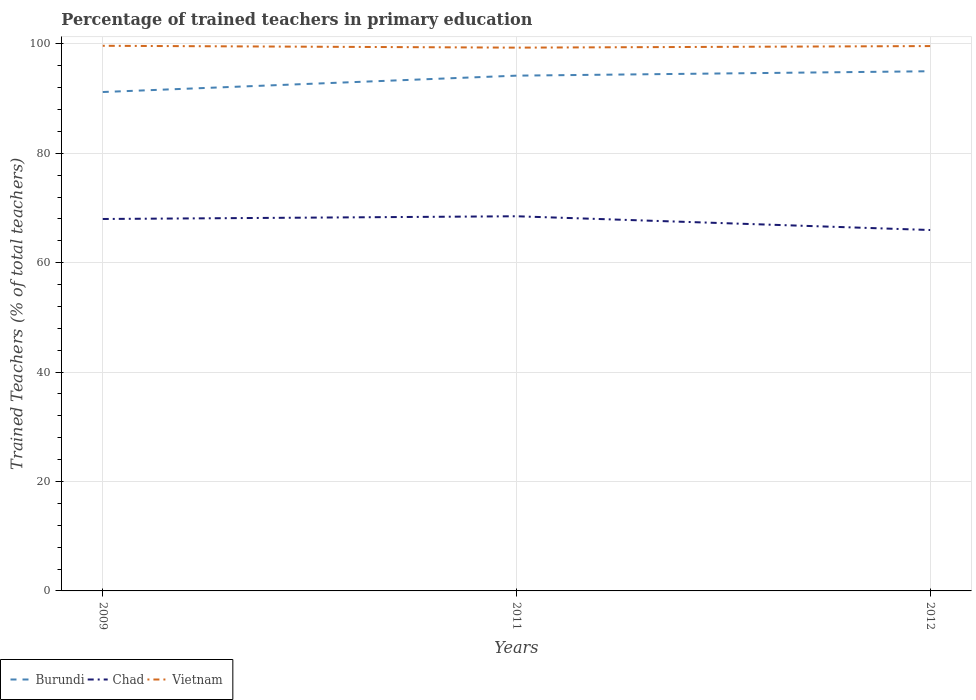How many different coloured lines are there?
Your answer should be very brief. 3. Across all years, what is the maximum percentage of trained teachers in Chad?
Provide a short and direct response. 65.97. What is the total percentage of trained teachers in Vietnam in the graph?
Make the answer very short. -0.29. What is the difference between the highest and the second highest percentage of trained teachers in Vietnam?
Give a very brief answer. 0.34. Is the percentage of trained teachers in Vietnam strictly greater than the percentage of trained teachers in Burundi over the years?
Give a very brief answer. No. How many lines are there?
Give a very brief answer. 3. What is the difference between two consecutive major ticks on the Y-axis?
Keep it short and to the point. 20. Are the values on the major ticks of Y-axis written in scientific E-notation?
Provide a succinct answer. No. Does the graph contain any zero values?
Your response must be concise. No. Does the graph contain grids?
Offer a terse response. Yes. Where does the legend appear in the graph?
Provide a short and direct response. Bottom left. How are the legend labels stacked?
Make the answer very short. Horizontal. What is the title of the graph?
Ensure brevity in your answer.  Percentage of trained teachers in primary education. Does "Panama" appear as one of the legend labels in the graph?
Ensure brevity in your answer.  No. What is the label or title of the X-axis?
Your answer should be very brief. Years. What is the label or title of the Y-axis?
Your answer should be compact. Trained Teachers (% of total teachers). What is the Trained Teachers (% of total teachers) of Burundi in 2009?
Offer a terse response. 91.19. What is the Trained Teachers (% of total teachers) of Chad in 2009?
Give a very brief answer. 67.98. What is the Trained Teachers (% of total teachers) of Vietnam in 2009?
Provide a succinct answer. 99.64. What is the Trained Teachers (% of total teachers) of Burundi in 2011?
Your response must be concise. 94.18. What is the Trained Teachers (% of total teachers) in Chad in 2011?
Give a very brief answer. 68.48. What is the Trained Teachers (% of total teachers) in Vietnam in 2011?
Provide a short and direct response. 99.3. What is the Trained Teachers (% of total teachers) of Burundi in 2012?
Ensure brevity in your answer.  94.99. What is the Trained Teachers (% of total teachers) of Chad in 2012?
Make the answer very short. 65.97. What is the Trained Teachers (% of total teachers) in Vietnam in 2012?
Keep it short and to the point. 99.59. Across all years, what is the maximum Trained Teachers (% of total teachers) in Burundi?
Make the answer very short. 94.99. Across all years, what is the maximum Trained Teachers (% of total teachers) in Chad?
Your answer should be very brief. 68.48. Across all years, what is the maximum Trained Teachers (% of total teachers) in Vietnam?
Keep it short and to the point. 99.64. Across all years, what is the minimum Trained Teachers (% of total teachers) in Burundi?
Make the answer very short. 91.19. Across all years, what is the minimum Trained Teachers (% of total teachers) in Chad?
Offer a terse response. 65.97. Across all years, what is the minimum Trained Teachers (% of total teachers) of Vietnam?
Keep it short and to the point. 99.3. What is the total Trained Teachers (% of total teachers) of Burundi in the graph?
Offer a terse response. 280.36. What is the total Trained Teachers (% of total teachers) of Chad in the graph?
Offer a terse response. 202.43. What is the total Trained Teachers (% of total teachers) of Vietnam in the graph?
Your response must be concise. 298.53. What is the difference between the Trained Teachers (% of total teachers) of Burundi in 2009 and that in 2011?
Your answer should be very brief. -2.99. What is the difference between the Trained Teachers (% of total teachers) of Chad in 2009 and that in 2011?
Ensure brevity in your answer.  -0.5. What is the difference between the Trained Teachers (% of total teachers) in Vietnam in 2009 and that in 2011?
Your response must be concise. 0.34. What is the difference between the Trained Teachers (% of total teachers) of Burundi in 2009 and that in 2012?
Provide a short and direct response. -3.8. What is the difference between the Trained Teachers (% of total teachers) of Chad in 2009 and that in 2012?
Keep it short and to the point. 2.02. What is the difference between the Trained Teachers (% of total teachers) in Vietnam in 2009 and that in 2012?
Give a very brief answer. 0.05. What is the difference between the Trained Teachers (% of total teachers) of Burundi in 2011 and that in 2012?
Offer a terse response. -0.81. What is the difference between the Trained Teachers (% of total teachers) of Chad in 2011 and that in 2012?
Provide a short and direct response. 2.51. What is the difference between the Trained Teachers (% of total teachers) of Vietnam in 2011 and that in 2012?
Give a very brief answer. -0.29. What is the difference between the Trained Teachers (% of total teachers) in Burundi in 2009 and the Trained Teachers (% of total teachers) in Chad in 2011?
Offer a very short reply. 22.71. What is the difference between the Trained Teachers (% of total teachers) of Burundi in 2009 and the Trained Teachers (% of total teachers) of Vietnam in 2011?
Offer a terse response. -8.11. What is the difference between the Trained Teachers (% of total teachers) of Chad in 2009 and the Trained Teachers (% of total teachers) of Vietnam in 2011?
Offer a terse response. -31.32. What is the difference between the Trained Teachers (% of total teachers) in Burundi in 2009 and the Trained Teachers (% of total teachers) in Chad in 2012?
Ensure brevity in your answer.  25.22. What is the difference between the Trained Teachers (% of total teachers) of Burundi in 2009 and the Trained Teachers (% of total teachers) of Vietnam in 2012?
Ensure brevity in your answer.  -8.4. What is the difference between the Trained Teachers (% of total teachers) in Chad in 2009 and the Trained Teachers (% of total teachers) in Vietnam in 2012?
Your response must be concise. -31.61. What is the difference between the Trained Teachers (% of total teachers) of Burundi in 2011 and the Trained Teachers (% of total teachers) of Chad in 2012?
Your answer should be very brief. 28.22. What is the difference between the Trained Teachers (% of total teachers) in Burundi in 2011 and the Trained Teachers (% of total teachers) in Vietnam in 2012?
Your response must be concise. -5.41. What is the difference between the Trained Teachers (% of total teachers) of Chad in 2011 and the Trained Teachers (% of total teachers) of Vietnam in 2012?
Your answer should be very brief. -31.11. What is the average Trained Teachers (% of total teachers) of Burundi per year?
Make the answer very short. 93.45. What is the average Trained Teachers (% of total teachers) of Chad per year?
Make the answer very short. 67.48. What is the average Trained Teachers (% of total teachers) in Vietnam per year?
Keep it short and to the point. 99.51. In the year 2009, what is the difference between the Trained Teachers (% of total teachers) of Burundi and Trained Teachers (% of total teachers) of Chad?
Provide a succinct answer. 23.21. In the year 2009, what is the difference between the Trained Teachers (% of total teachers) in Burundi and Trained Teachers (% of total teachers) in Vietnam?
Your answer should be very brief. -8.45. In the year 2009, what is the difference between the Trained Teachers (% of total teachers) in Chad and Trained Teachers (% of total teachers) in Vietnam?
Offer a terse response. -31.66. In the year 2011, what is the difference between the Trained Teachers (% of total teachers) in Burundi and Trained Teachers (% of total teachers) in Chad?
Offer a terse response. 25.7. In the year 2011, what is the difference between the Trained Teachers (% of total teachers) of Burundi and Trained Teachers (% of total teachers) of Vietnam?
Offer a very short reply. -5.12. In the year 2011, what is the difference between the Trained Teachers (% of total teachers) in Chad and Trained Teachers (% of total teachers) in Vietnam?
Give a very brief answer. -30.82. In the year 2012, what is the difference between the Trained Teachers (% of total teachers) of Burundi and Trained Teachers (% of total teachers) of Chad?
Give a very brief answer. 29.02. In the year 2012, what is the difference between the Trained Teachers (% of total teachers) in Burundi and Trained Teachers (% of total teachers) in Vietnam?
Keep it short and to the point. -4.6. In the year 2012, what is the difference between the Trained Teachers (% of total teachers) of Chad and Trained Teachers (% of total teachers) of Vietnam?
Make the answer very short. -33.62. What is the ratio of the Trained Teachers (% of total teachers) of Burundi in 2009 to that in 2011?
Your answer should be compact. 0.97. What is the ratio of the Trained Teachers (% of total teachers) in Vietnam in 2009 to that in 2011?
Your answer should be very brief. 1. What is the ratio of the Trained Teachers (% of total teachers) of Chad in 2009 to that in 2012?
Your answer should be very brief. 1.03. What is the ratio of the Trained Teachers (% of total teachers) of Burundi in 2011 to that in 2012?
Offer a terse response. 0.99. What is the ratio of the Trained Teachers (% of total teachers) of Chad in 2011 to that in 2012?
Your response must be concise. 1.04. What is the difference between the highest and the second highest Trained Teachers (% of total teachers) in Burundi?
Provide a short and direct response. 0.81. What is the difference between the highest and the second highest Trained Teachers (% of total teachers) in Chad?
Offer a terse response. 0.5. What is the difference between the highest and the second highest Trained Teachers (% of total teachers) of Vietnam?
Make the answer very short. 0.05. What is the difference between the highest and the lowest Trained Teachers (% of total teachers) of Burundi?
Keep it short and to the point. 3.8. What is the difference between the highest and the lowest Trained Teachers (% of total teachers) of Chad?
Keep it short and to the point. 2.51. What is the difference between the highest and the lowest Trained Teachers (% of total teachers) of Vietnam?
Offer a very short reply. 0.34. 